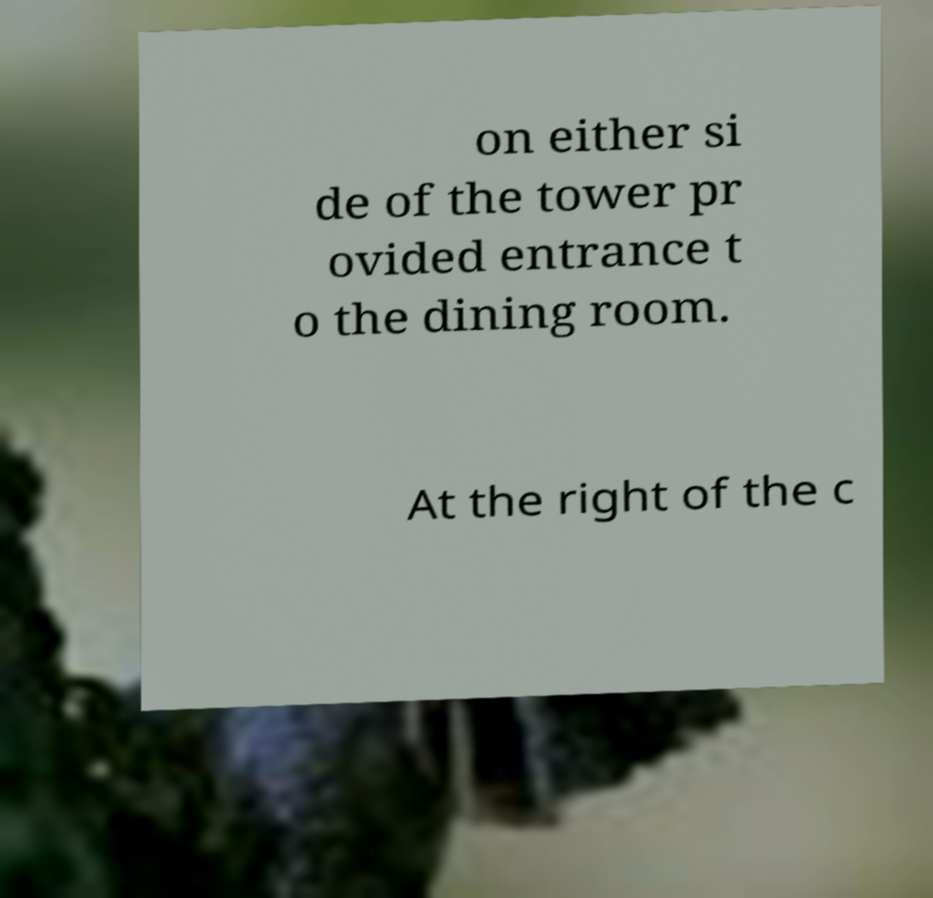Can you accurately transcribe the text from the provided image for me? on either si de of the tower pr ovided entrance t o the dining room. At the right of the c 